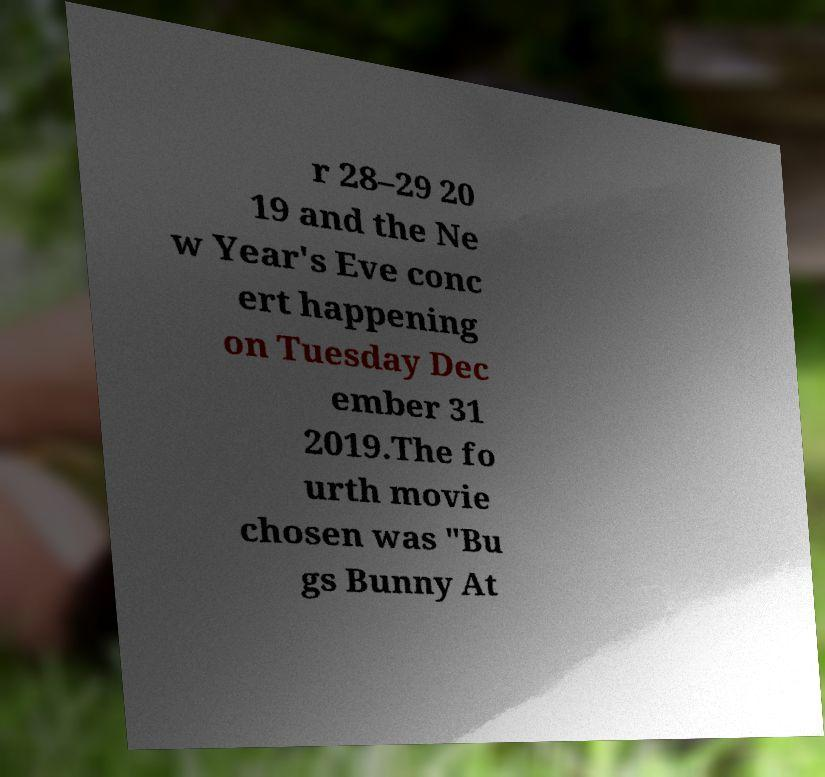Please identify and transcribe the text found in this image. r 28–29 20 19 and the Ne w Year's Eve conc ert happening on Tuesday Dec ember 31 2019.The fo urth movie chosen was "Bu gs Bunny At 